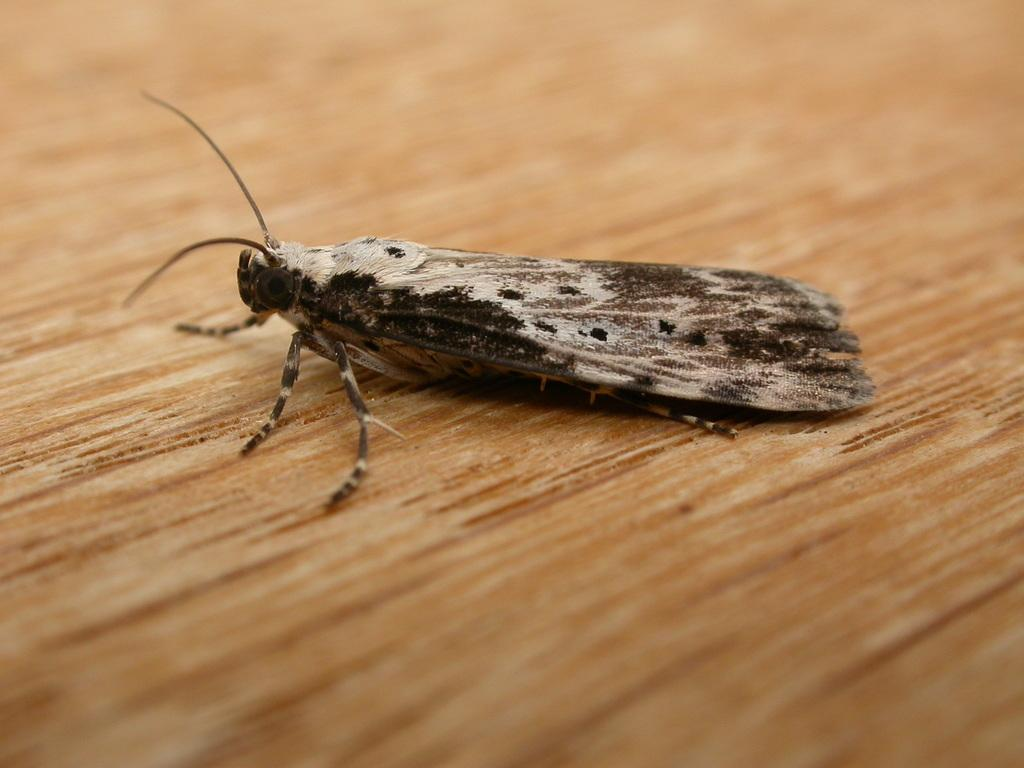What type of creature is present in the image? There is an insect in the image. What colors can be seen on the insect? The insect has cream, black, and brown colors. What is the insect resting on in the image? The insect is on a brown and cream colored surface. What type of discussion is taking place between the insect and the bed in the image? There is no bed present in the image, and therefore no discussion can be observed between the insect and a bed. 